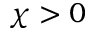Convert formula to latex. <formula><loc_0><loc_0><loc_500><loc_500>\chi > 0</formula> 